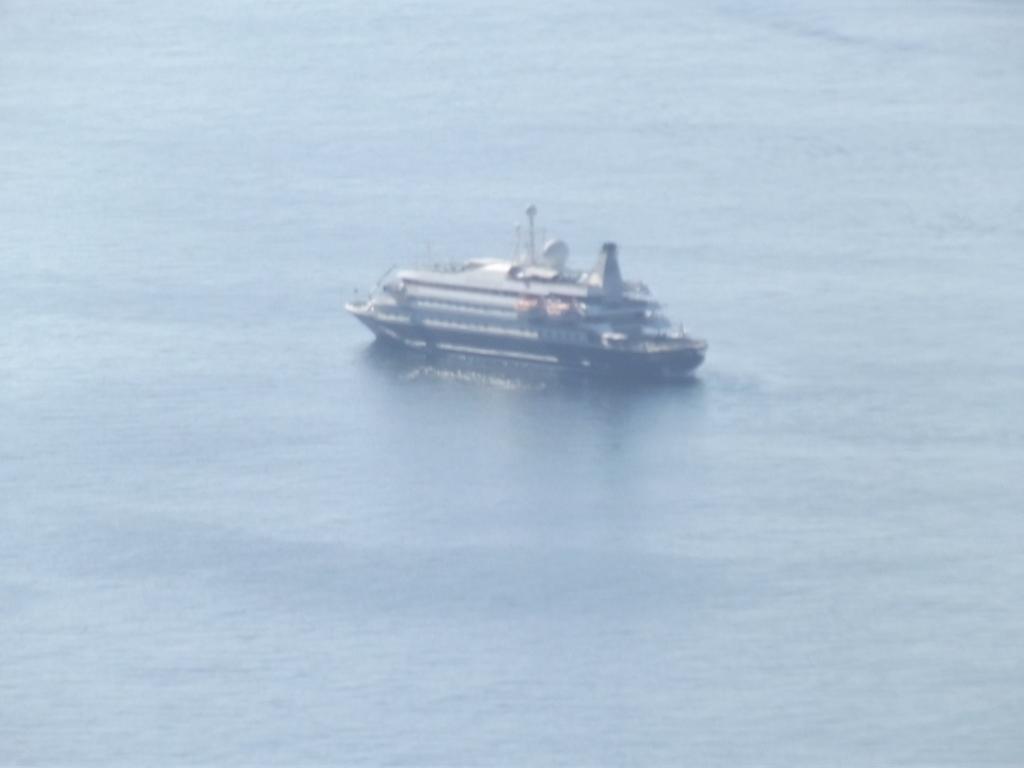Describe this image in one or two sentences. In this image I can see water and a ship in it. 